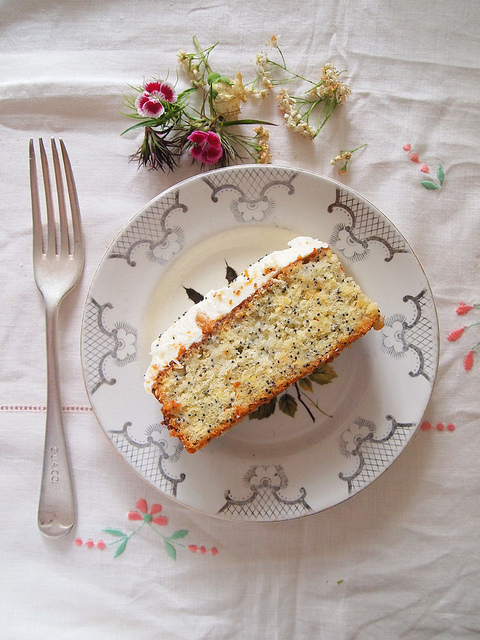Imagine a story behind this image. Who might have prepared this cake and for what purpose? The image captures a beautifully crafted scene that appears to tell a story of love and celebration. Imagine an elderly grandmother, renowned in her family for her baking prowess, carefully preparing this poppy seed cake for her granddaughter's engagement party. The meticulous details, from the delicate frosting to the lovingly arranged flowers, speak of her affection and pride. She places the cake on a vintage, cherished family heirloom plate, signifying tradition and continuity. As the family gathers around to celebrate, this cake will not only be a treat for the taste buds but a vessel of cherished memories and familial bonds. 